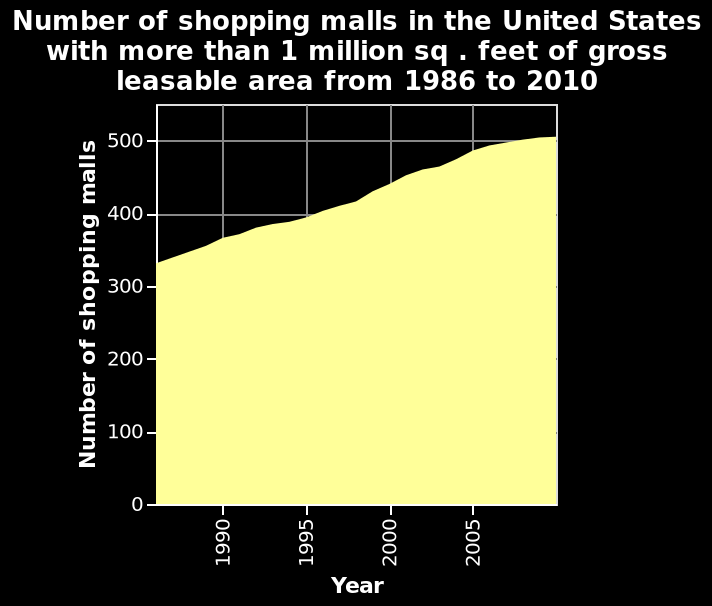<image>
please enumerates aspects of the construction of the chart Here a is a area graph named Number of shopping malls in the United States with more than 1 million sq . feet of gross leasable area from 1986 to 2010. The x-axis shows Year while the y-axis plots Number of shopping malls. 